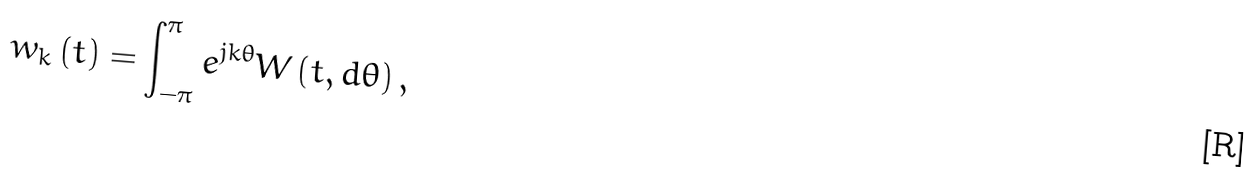<formula> <loc_0><loc_0><loc_500><loc_500>w _ { k } \left ( t \right ) = \int _ { - \pi } ^ { \pi } e ^ { j k \theta } W \left ( t , d \theta \right ) ,</formula> 